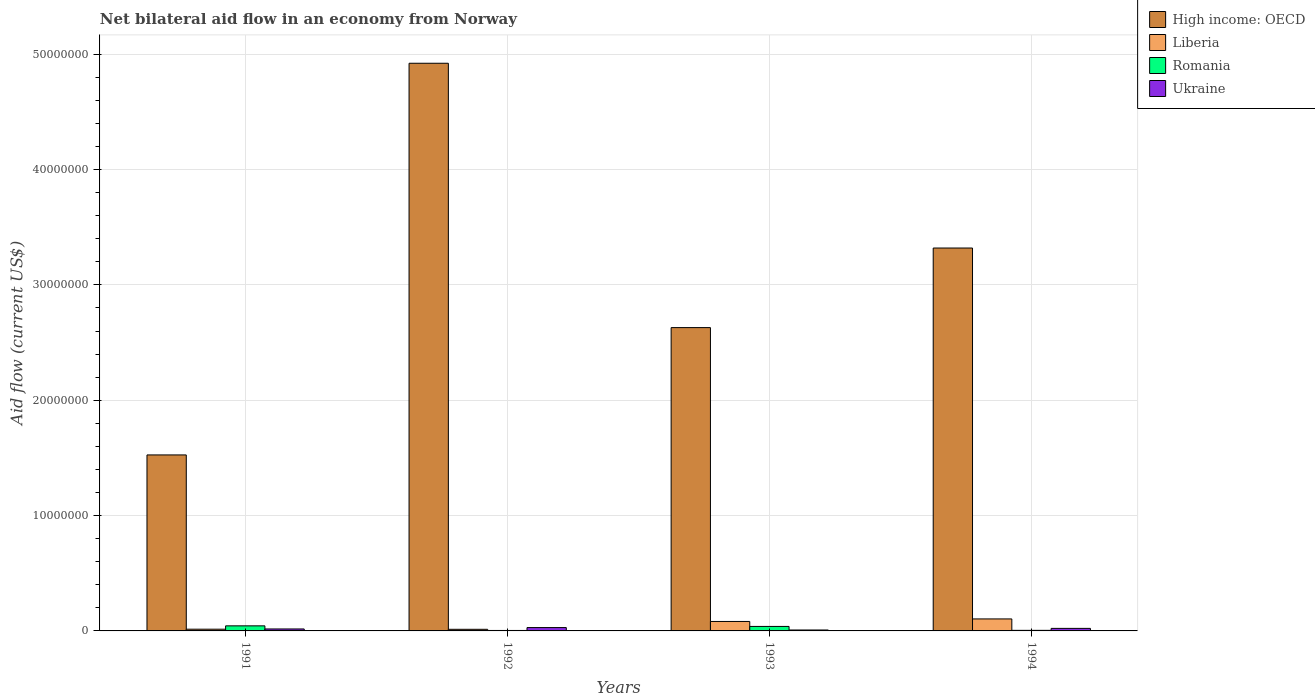How many different coloured bars are there?
Your answer should be very brief. 4. How many bars are there on the 4th tick from the left?
Give a very brief answer. 4. What is the label of the 4th group of bars from the left?
Your response must be concise. 1994. In how many cases, is the number of bars for a given year not equal to the number of legend labels?
Keep it short and to the point. 0. What is the net bilateral aid flow in Romania in 1993?
Make the answer very short. 3.90e+05. Across all years, what is the minimum net bilateral aid flow in High income: OECD?
Offer a very short reply. 1.53e+07. In which year was the net bilateral aid flow in High income: OECD minimum?
Your answer should be very brief. 1991. What is the total net bilateral aid flow in Romania in the graph?
Provide a short and direct response. 9.20e+05. What is the difference between the net bilateral aid flow in Romania in 1991 and that in 1992?
Offer a very short reply. 4.00e+05. What is the average net bilateral aid flow in Ukraine per year?
Offer a very short reply. 1.90e+05. In the year 1991, what is the difference between the net bilateral aid flow in Ukraine and net bilateral aid flow in High income: OECD?
Make the answer very short. -1.51e+07. In how many years, is the net bilateral aid flow in Liberia greater than 6000000 US$?
Provide a succinct answer. 0. What is the ratio of the net bilateral aid flow in Romania in 1991 to that in 1994?
Your response must be concise. 8.8. Is the net bilateral aid flow in Liberia in 1992 less than that in 1994?
Offer a terse response. Yes. Is the difference between the net bilateral aid flow in Ukraine in 1991 and 1994 greater than the difference between the net bilateral aid flow in High income: OECD in 1991 and 1994?
Your answer should be compact. Yes. What is the difference between the highest and the lowest net bilateral aid flow in High income: OECD?
Your response must be concise. 3.40e+07. In how many years, is the net bilateral aid flow in Romania greater than the average net bilateral aid flow in Romania taken over all years?
Keep it short and to the point. 2. What does the 2nd bar from the left in 1992 represents?
Your answer should be very brief. Liberia. What does the 4th bar from the right in 1994 represents?
Your answer should be compact. High income: OECD. Is it the case that in every year, the sum of the net bilateral aid flow in Romania and net bilateral aid flow in Liberia is greater than the net bilateral aid flow in Ukraine?
Your response must be concise. No. How many bars are there?
Your response must be concise. 16. Are all the bars in the graph horizontal?
Ensure brevity in your answer.  No. What is the difference between two consecutive major ticks on the Y-axis?
Offer a terse response. 1.00e+07. Does the graph contain any zero values?
Your response must be concise. No. How many legend labels are there?
Your response must be concise. 4. What is the title of the graph?
Your response must be concise. Net bilateral aid flow in an economy from Norway. What is the label or title of the X-axis?
Your answer should be compact. Years. What is the label or title of the Y-axis?
Offer a terse response. Aid flow (current US$). What is the Aid flow (current US$) in High income: OECD in 1991?
Keep it short and to the point. 1.53e+07. What is the Aid flow (current US$) in Romania in 1991?
Your answer should be compact. 4.40e+05. What is the Aid flow (current US$) in High income: OECD in 1992?
Offer a very short reply. 4.92e+07. What is the Aid flow (current US$) of Liberia in 1992?
Offer a terse response. 1.40e+05. What is the Aid flow (current US$) of Romania in 1992?
Your response must be concise. 4.00e+04. What is the Aid flow (current US$) of Ukraine in 1992?
Ensure brevity in your answer.  2.90e+05. What is the Aid flow (current US$) in High income: OECD in 1993?
Keep it short and to the point. 2.63e+07. What is the Aid flow (current US$) in Liberia in 1993?
Your answer should be very brief. 8.20e+05. What is the Aid flow (current US$) of Ukraine in 1993?
Your answer should be compact. 8.00e+04. What is the Aid flow (current US$) in High income: OECD in 1994?
Your response must be concise. 3.32e+07. What is the Aid flow (current US$) of Liberia in 1994?
Provide a short and direct response. 1.04e+06. Across all years, what is the maximum Aid flow (current US$) in High income: OECD?
Offer a very short reply. 4.92e+07. Across all years, what is the maximum Aid flow (current US$) in Liberia?
Keep it short and to the point. 1.04e+06. Across all years, what is the maximum Aid flow (current US$) of Ukraine?
Provide a short and direct response. 2.90e+05. Across all years, what is the minimum Aid flow (current US$) in High income: OECD?
Provide a succinct answer. 1.53e+07. Across all years, what is the minimum Aid flow (current US$) in Liberia?
Ensure brevity in your answer.  1.40e+05. What is the total Aid flow (current US$) of High income: OECD in the graph?
Your answer should be compact. 1.24e+08. What is the total Aid flow (current US$) in Liberia in the graph?
Offer a terse response. 2.15e+06. What is the total Aid flow (current US$) of Romania in the graph?
Give a very brief answer. 9.20e+05. What is the total Aid flow (current US$) of Ukraine in the graph?
Provide a short and direct response. 7.60e+05. What is the difference between the Aid flow (current US$) in High income: OECD in 1991 and that in 1992?
Ensure brevity in your answer.  -3.40e+07. What is the difference between the Aid flow (current US$) in Romania in 1991 and that in 1992?
Your answer should be very brief. 4.00e+05. What is the difference between the Aid flow (current US$) of High income: OECD in 1991 and that in 1993?
Make the answer very short. -1.10e+07. What is the difference between the Aid flow (current US$) in Liberia in 1991 and that in 1993?
Your response must be concise. -6.70e+05. What is the difference between the Aid flow (current US$) in Romania in 1991 and that in 1993?
Give a very brief answer. 5.00e+04. What is the difference between the Aid flow (current US$) in High income: OECD in 1991 and that in 1994?
Ensure brevity in your answer.  -1.79e+07. What is the difference between the Aid flow (current US$) of Liberia in 1991 and that in 1994?
Your answer should be very brief. -8.90e+05. What is the difference between the Aid flow (current US$) in High income: OECD in 1992 and that in 1993?
Your response must be concise. 2.29e+07. What is the difference between the Aid flow (current US$) of Liberia in 1992 and that in 1993?
Keep it short and to the point. -6.80e+05. What is the difference between the Aid flow (current US$) of Romania in 1992 and that in 1993?
Provide a short and direct response. -3.50e+05. What is the difference between the Aid flow (current US$) in High income: OECD in 1992 and that in 1994?
Make the answer very short. 1.60e+07. What is the difference between the Aid flow (current US$) in Liberia in 1992 and that in 1994?
Your response must be concise. -9.00e+05. What is the difference between the Aid flow (current US$) in Romania in 1992 and that in 1994?
Give a very brief answer. -10000. What is the difference between the Aid flow (current US$) of High income: OECD in 1993 and that in 1994?
Provide a short and direct response. -6.90e+06. What is the difference between the Aid flow (current US$) of Liberia in 1993 and that in 1994?
Provide a succinct answer. -2.20e+05. What is the difference between the Aid flow (current US$) in Romania in 1993 and that in 1994?
Offer a very short reply. 3.40e+05. What is the difference between the Aid flow (current US$) of Ukraine in 1993 and that in 1994?
Provide a short and direct response. -1.40e+05. What is the difference between the Aid flow (current US$) of High income: OECD in 1991 and the Aid flow (current US$) of Liberia in 1992?
Make the answer very short. 1.51e+07. What is the difference between the Aid flow (current US$) in High income: OECD in 1991 and the Aid flow (current US$) in Romania in 1992?
Your answer should be compact. 1.52e+07. What is the difference between the Aid flow (current US$) of High income: OECD in 1991 and the Aid flow (current US$) of Ukraine in 1992?
Make the answer very short. 1.50e+07. What is the difference between the Aid flow (current US$) in Romania in 1991 and the Aid flow (current US$) in Ukraine in 1992?
Provide a succinct answer. 1.50e+05. What is the difference between the Aid flow (current US$) of High income: OECD in 1991 and the Aid flow (current US$) of Liberia in 1993?
Provide a short and direct response. 1.44e+07. What is the difference between the Aid flow (current US$) of High income: OECD in 1991 and the Aid flow (current US$) of Romania in 1993?
Make the answer very short. 1.49e+07. What is the difference between the Aid flow (current US$) of High income: OECD in 1991 and the Aid flow (current US$) of Ukraine in 1993?
Provide a short and direct response. 1.52e+07. What is the difference between the Aid flow (current US$) in Liberia in 1991 and the Aid flow (current US$) in Romania in 1993?
Your answer should be very brief. -2.40e+05. What is the difference between the Aid flow (current US$) of High income: OECD in 1991 and the Aid flow (current US$) of Liberia in 1994?
Give a very brief answer. 1.42e+07. What is the difference between the Aid flow (current US$) of High income: OECD in 1991 and the Aid flow (current US$) of Romania in 1994?
Your response must be concise. 1.52e+07. What is the difference between the Aid flow (current US$) of High income: OECD in 1991 and the Aid flow (current US$) of Ukraine in 1994?
Ensure brevity in your answer.  1.50e+07. What is the difference between the Aid flow (current US$) in Romania in 1991 and the Aid flow (current US$) in Ukraine in 1994?
Give a very brief answer. 2.20e+05. What is the difference between the Aid flow (current US$) of High income: OECD in 1992 and the Aid flow (current US$) of Liberia in 1993?
Give a very brief answer. 4.84e+07. What is the difference between the Aid flow (current US$) in High income: OECD in 1992 and the Aid flow (current US$) in Romania in 1993?
Keep it short and to the point. 4.88e+07. What is the difference between the Aid flow (current US$) of High income: OECD in 1992 and the Aid flow (current US$) of Ukraine in 1993?
Your answer should be compact. 4.91e+07. What is the difference between the Aid flow (current US$) in Liberia in 1992 and the Aid flow (current US$) in Romania in 1993?
Provide a short and direct response. -2.50e+05. What is the difference between the Aid flow (current US$) of High income: OECD in 1992 and the Aid flow (current US$) of Liberia in 1994?
Your answer should be compact. 4.82e+07. What is the difference between the Aid flow (current US$) in High income: OECD in 1992 and the Aid flow (current US$) in Romania in 1994?
Offer a terse response. 4.92e+07. What is the difference between the Aid flow (current US$) of High income: OECD in 1992 and the Aid flow (current US$) of Ukraine in 1994?
Offer a very short reply. 4.90e+07. What is the difference between the Aid flow (current US$) in High income: OECD in 1993 and the Aid flow (current US$) in Liberia in 1994?
Provide a succinct answer. 2.53e+07. What is the difference between the Aid flow (current US$) in High income: OECD in 1993 and the Aid flow (current US$) in Romania in 1994?
Offer a very short reply. 2.62e+07. What is the difference between the Aid flow (current US$) of High income: OECD in 1993 and the Aid flow (current US$) of Ukraine in 1994?
Provide a short and direct response. 2.61e+07. What is the difference between the Aid flow (current US$) in Liberia in 1993 and the Aid flow (current US$) in Romania in 1994?
Offer a terse response. 7.70e+05. What is the average Aid flow (current US$) of High income: OECD per year?
Offer a terse response. 3.10e+07. What is the average Aid flow (current US$) in Liberia per year?
Make the answer very short. 5.38e+05. In the year 1991, what is the difference between the Aid flow (current US$) in High income: OECD and Aid flow (current US$) in Liberia?
Your answer should be very brief. 1.51e+07. In the year 1991, what is the difference between the Aid flow (current US$) in High income: OECD and Aid flow (current US$) in Romania?
Your response must be concise. 1.48e+07. In the year 1991, what is the difference between the Aid flow (current US$) in High income: OECD and Aid flow (current US$) in Ukraine?
Your answer should be very brief. 1.51e+07. In the year 1991, what is the difference between the Aid flow (current US$) in Liberia and Aid flow (current US$) in Ukraine?
Provide a succinct answer. -2.00e+04. In the year 1992, what is the difference between the Aid flow (current US$) of High income: OECD and Aid flow (current US$) of Liberia?
Provide a succinct answer. 4.91e+07. In the year 1992, what is the difference between the Aid flow (current US$) of High income: OECD and Aid flow (current US$) of Romania?
Ensure brevity in your answer.  4.92e+07. In the year 1992, what is the difference between the Aid flow (current US$) of High income: OECD and Aid flow (current US$) of Ukraine?
Keep it short and to the point. 4.89e+07. In the year 1993, what is the difference between the Aid flow (current US$) of High income: OECD and Aid flow (current US$) of Liberia?
Ensure brevity in your answer.  2.55e+07. In the year 1993, what is the difference between the Aid flow (current US$) in High income: OECD and Aid flow (current US$) in Romania?
Give a very brief answer. 2.59e+07. In the year 1993, what is the difference between the Aid flow (current US$) in High income: OECD and Aid flow (current US$) in Ukraine?
Your answer should be compact. 2.62e+07. In the year 1993, what is the difference between the Aid flow (current US$) of Liberia and Aid flow (current US$) of Ukraine?
Ensure brevity in your answer.  7.40e+05. In the year 1993, what is the difference between the Aid flow (current US$) in Romania and Aid flow (current US$) in Ukraine?
Your response must be concise. 3.10e+05. In the year 1994, what is the difference between the Aid flow (current US$) of High income: OECD and Aid flow (current US$) of Liberia?
Offer a terse response. 3.22e+07. In the year 1994, what is the difference between the Aid flow (current US$) of High income: OECD and Aid flow (current US$) of Romania?
Provide a succinct answer. 3.32e+07. In the year 1994, what is the difference between the Aid flow (current US$) in High income: OECD and Aid flow (current US$) in Ukraine?
Give a very brief answer. 3.30e+07. In the year 1994, what is the difference between the Aid flow (current US$) of Liberia and Aid flow (current US$) of Romania?
Your response must be concise. 9.90e+05. In the year 1994, what is the difference between the Aid flow (current US$) of Liberia and Aid flow (current US$) of Ukraine?
Offer a very short reply. 8.20e+05. In the year 1994, what is the difference between the Aid flow (current US$) of Romania and Aid flow (current US$) of Ukraine?
Ensure brevity in your answer.  -1.70e+05. What is the ratio of the Aid flow (current US$) in High income: OECD in 1991 to that in 1992?
Give a very brief answer. 0.31. What is the ratio of the Aid flow (current US$) in Liberia in 1991 to that in 1992?
Keep it short and to the point. 1.07. What is the ratio of the Aid flow (current US$) in Ukraine in 1991 to that in 1992?
Ensure brevity in your answer.  0.59. What is the ratio of the Aid flow (current US$) in High income: OECD in 1991 to that in 1993?
Offer a terse response. 0.58. What is the ratio of the Aid flow (current US$) of Liberia in 1991 to that in 1993?
Offer a terse response. 0.18. What is the ratio of the Aid flow (current US$) of Romania in 1991 to that in 1993?
Your response must be concise. 1.13. What is the ratio of the Aid flow (current US$) of Ukraine in 1991 to that in 1993?
Provide a succinct answer. 2.12. What is the ratio of the Aid flow (current US$) of High income: OECD in 1991 to that in 1994?
Your response must be concise. 0.46. What is the ratio of the Aid flow (current US$) of Liberia in 1991 to that in 1994?
Offer a terse response. 0.14. What is the ratio of the Aid flow (current US$) in Ukraine in 1991 to that in 1994?
Make the answer very short. 0.77. What is the ratio of the Aid flow (current US$) in High income: OECD in 1992 to that in 1993?
Your response must be concise. 1.87. What is the ratio of the Aid flow (current US$) in Liberia in 1992 to that in 1993?
Keep it short and to the point. 0.17. What is the ratio of the Aid flow (current US$) of Romania in 1992 to that in 1993?
Ensure brevity in your answer.  0.1. What is the ratio of the Aid flow (current US$) in Ukraine in 1992 to that in 1993?
Offer a terse response. 3.62. What is the ratio of the Aid flow (current US$) of High income: OECD in 1992 to that in 1994?
Give a very brief answer. 1.48. What is the ratio of the Aid flow (current US$) of Liberia in 1992 to that in 1994?
Your response must be concise. 0.13. What is the ratio of the Aid flow (current US$) in Ukraine in 1992 to that in 1994?
Your response must be concise. 1.32. What is the ratio of the Aid flow (current US$) in High income: OECD in 1993 to that in 1994?
Provide a succinct answer. 0.79. What is the ratio of the Aid flow (current US$) in Liberia in 1993 to that in 1994?
Provide a succinct answer. 0.79. What is the ratio of the Aid flow (current US$) in Romania in 1993 to that in 1994?
Your response must be concise. 7.8. What is the ratio of the Aid flow (current US$) of Ukraine in 1993 to that in 1994?
Your response must be concise. 0.36. What is the difference between the highest and the second highest Aid flow (current US$) of High income: OECD?
Give a very brief answer. 1.60e+07. What is the difference between the highest and the second highest Aid flow (current US$) of Liberia?
Ensure brevity in your answer.  2.20e+05. What is the difference between the highest and the second highest Aid flow (current US$) in Romania?
Ensure brevity in your answer.  5.00e+04. What is the difference between the highest and the lowest Aid flow (current US$) of High income: OECD?
Offer a terse response. 3.40e+07. What is the difference between the highest and the lowest Aid flow (current US$) in Liberia?
Offer a terse response. 9.00e+05. 